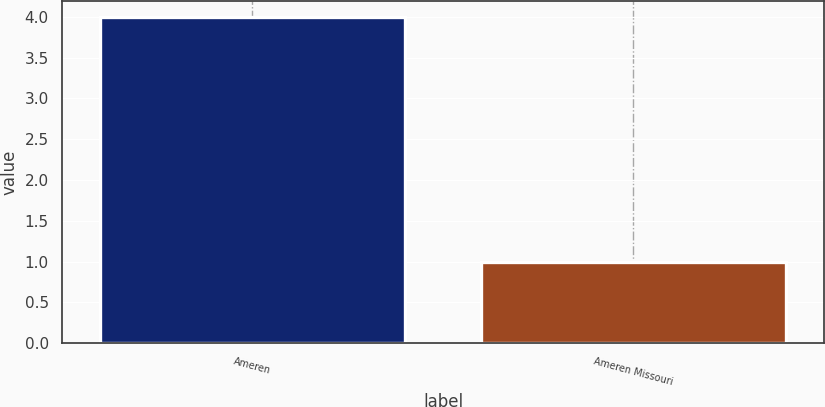<chart> <loc_0><loc_0><loc_500><loc_500><bar_chart><fcel>Ameren<fcel>Ameren Missouri<nl><fcel>4<fcel>1<nl></chart> 